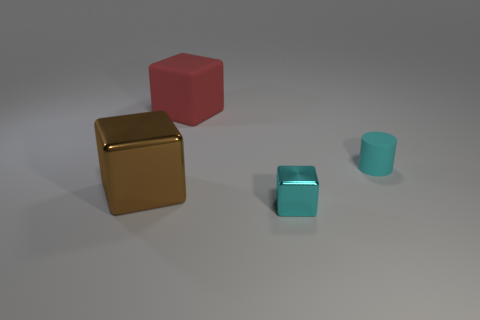What is the material of the tiny cube that is the same color as the tiny matte object?
Provide a short and direct response. Metal. Are there any other things that have the same shape as the cyan matte thing?
Your response must be concise. No. How many things are either metallic objects left of the rubber block or cubes that are right of the large red object?
Your response must be concise. 2. Do the brown metal cube and the cyan rubber thing have the same size?
Ensure brevity in your answer.  No. Are there more brown cubes than gray spheres?
Provide a succinct answer. Yes. How many other things are the same color as the tiny cylinder?
Your answer should be compact. 1. How many things are yellow metallic blocks or brown things?
Offer a terse response. 1. Does the big thing behind the big brown metal thing have the same shape as the cyan metallic object?
Make the answer very short. Yes. The big object that is on the left side of the big object behind the brown object is what color?
Your answer should be very brief. Brown. Is the number of large yellow rubber objects less than the number of rubber things?
Provide a short and direct response. Yes. 